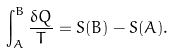Convert formula to latex. <formula><loc_0><loc_0><loc_500><loc_500>\int _ { A } ^ { B } \frac { \delta Q } { T } = S ( B ) - S ( A ) .</formula> 